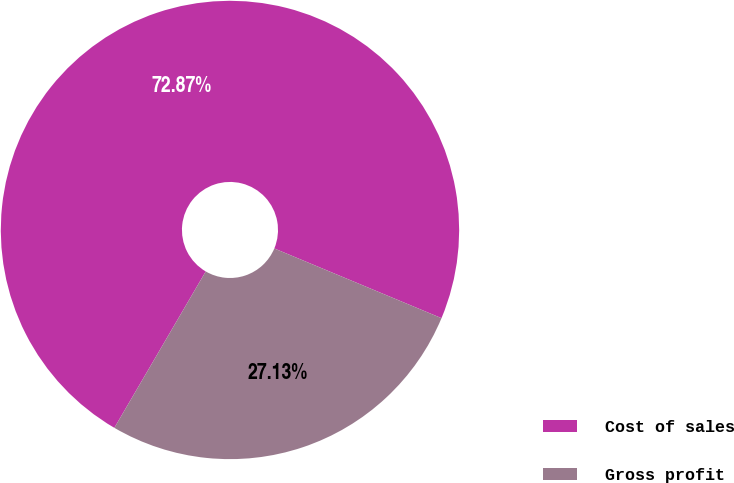<chart> <loc_0><loc_0><loc_500><loc_500><pie_chart><fcel>Cost of sales<fcel>Gross profit<nl><fcel>72.87%<fcel>27.13%<nl></chart> 